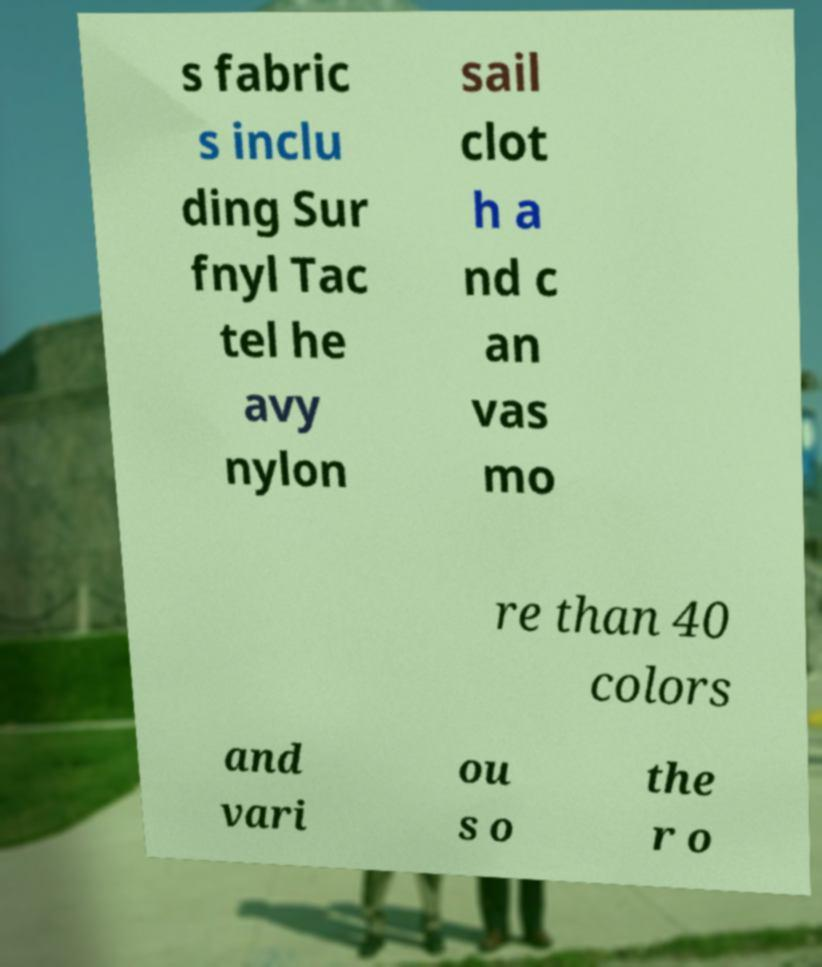Could you assist in decoding the text presented in this image and type it out clearly? s fabric s inclu ding Sur fnyl Tac tel he avy nylon sail clot h a nd c an vas mo re than 40 colors and vari ou s o the r o 